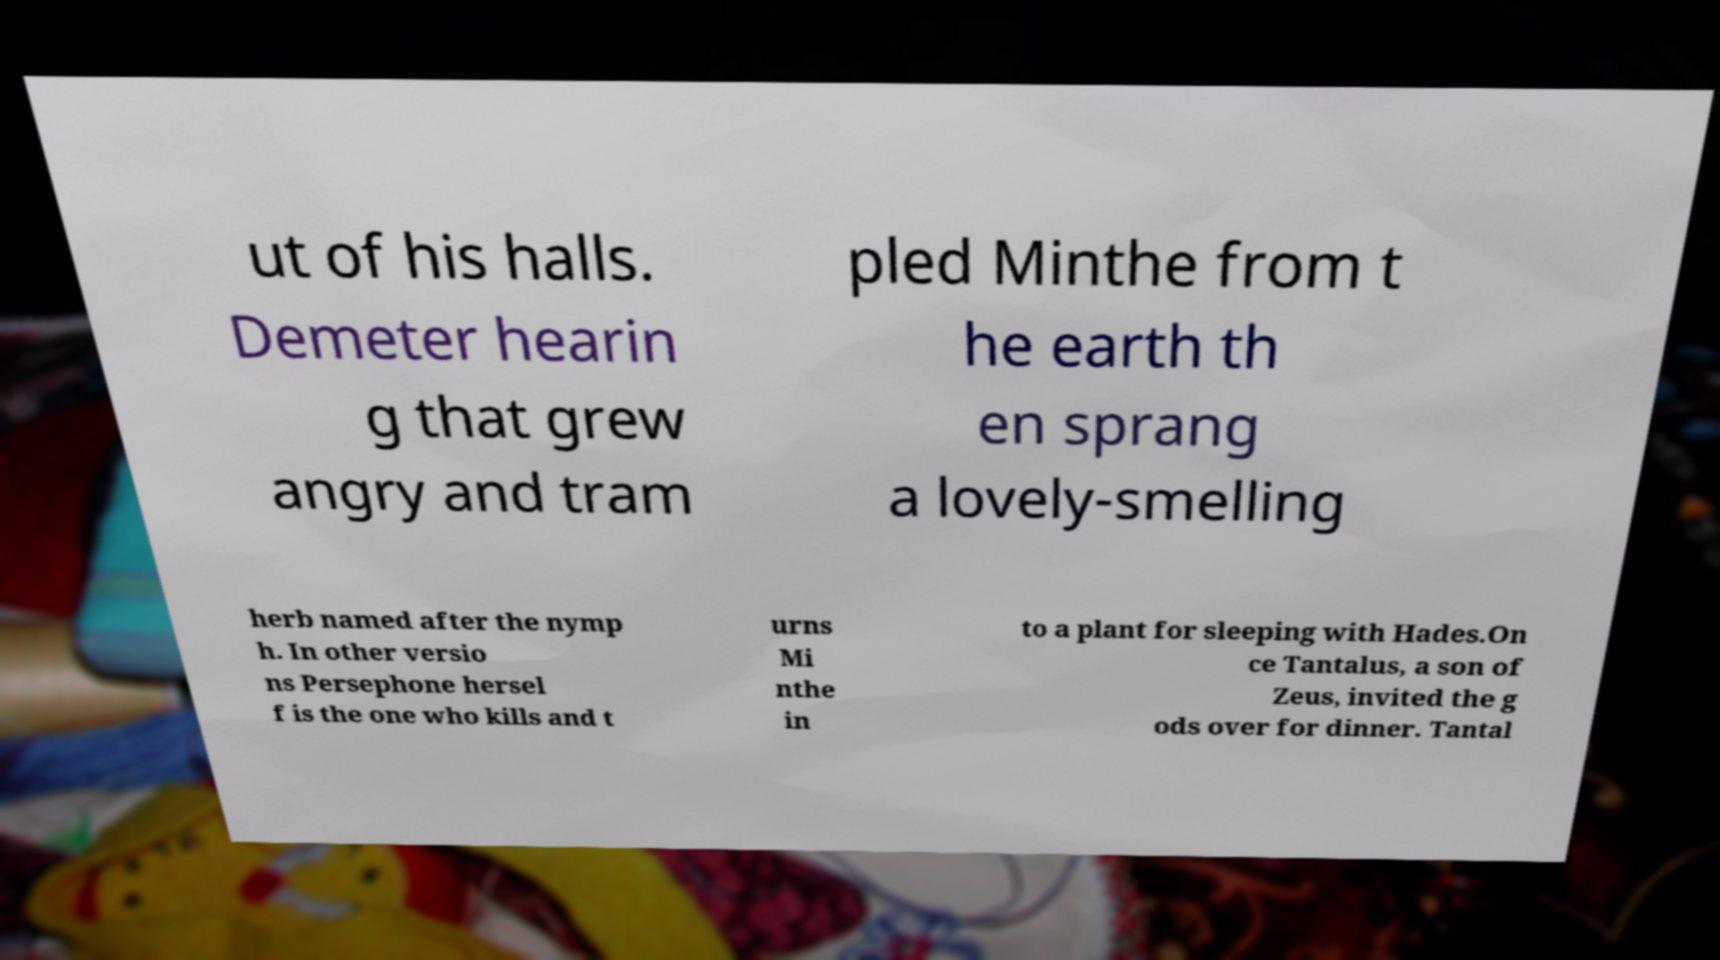There's text embedded in this image that I need extracted. Can you transcribe it verbatim? ut of his halls. Demeter hearin g that grew angry and tram pled Minthe from t he earth th en sprang a lovely-smelling herb named after the nymp h. In other versio ns Persephone hersel f is the one who kills and t urns Mi nthe in to a plant for sleeping with Hades.On ce Tantalus, a son of Zeus, invited the g ods over for dinner. Tantal 